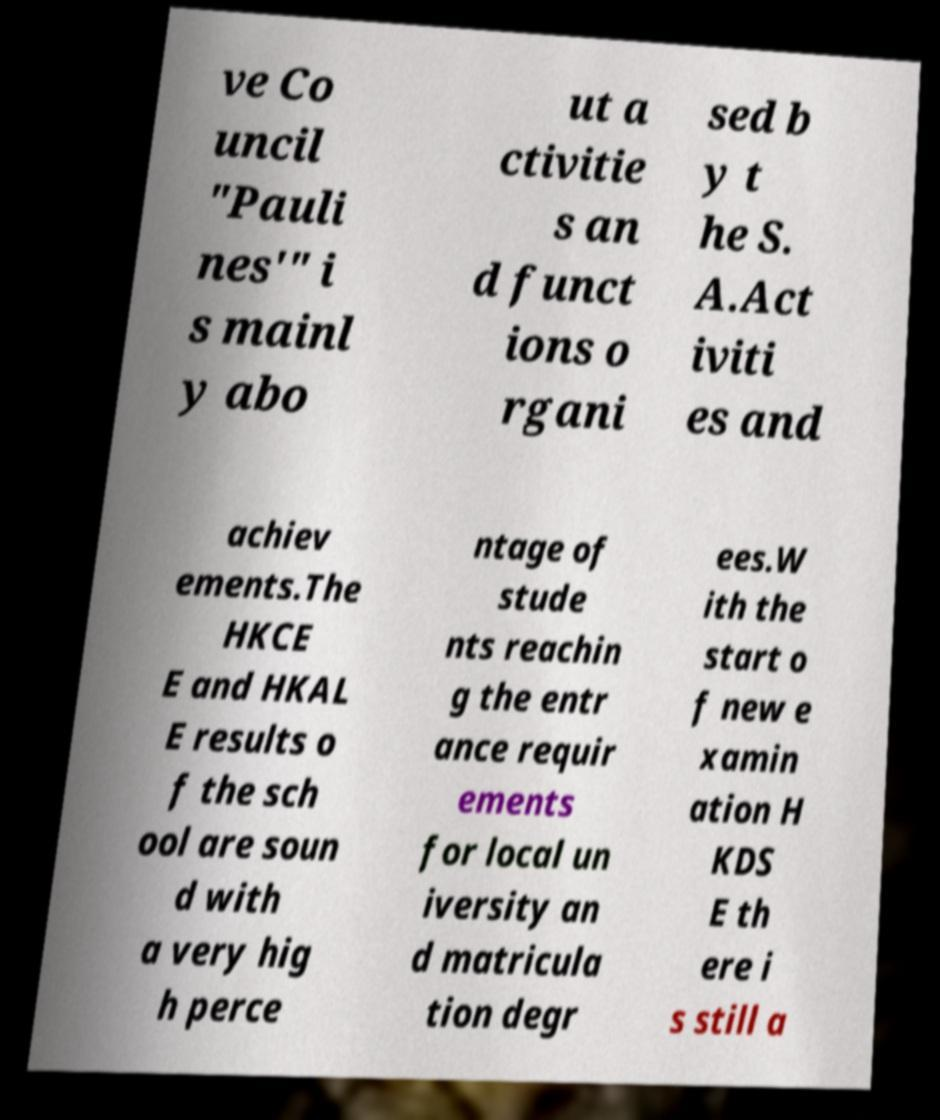Could you assist in decoding the text presented in this image and type it out clearly? ve Co uncil "Pauli nes'" i s mainl y abo ut a ctivitie s an d funct ions o rgani sed b y t he S. A.Act iviti es and achiev ements.The HKCE E and HKAL E results o f the sch ool are soun d with a very hig h perce ntage of stude nts reachin g the entr ance requir ements for local un iversity an d matricula tion degr ees.W ith the start o f new e xamin ation H KDS E th ere i s still a 